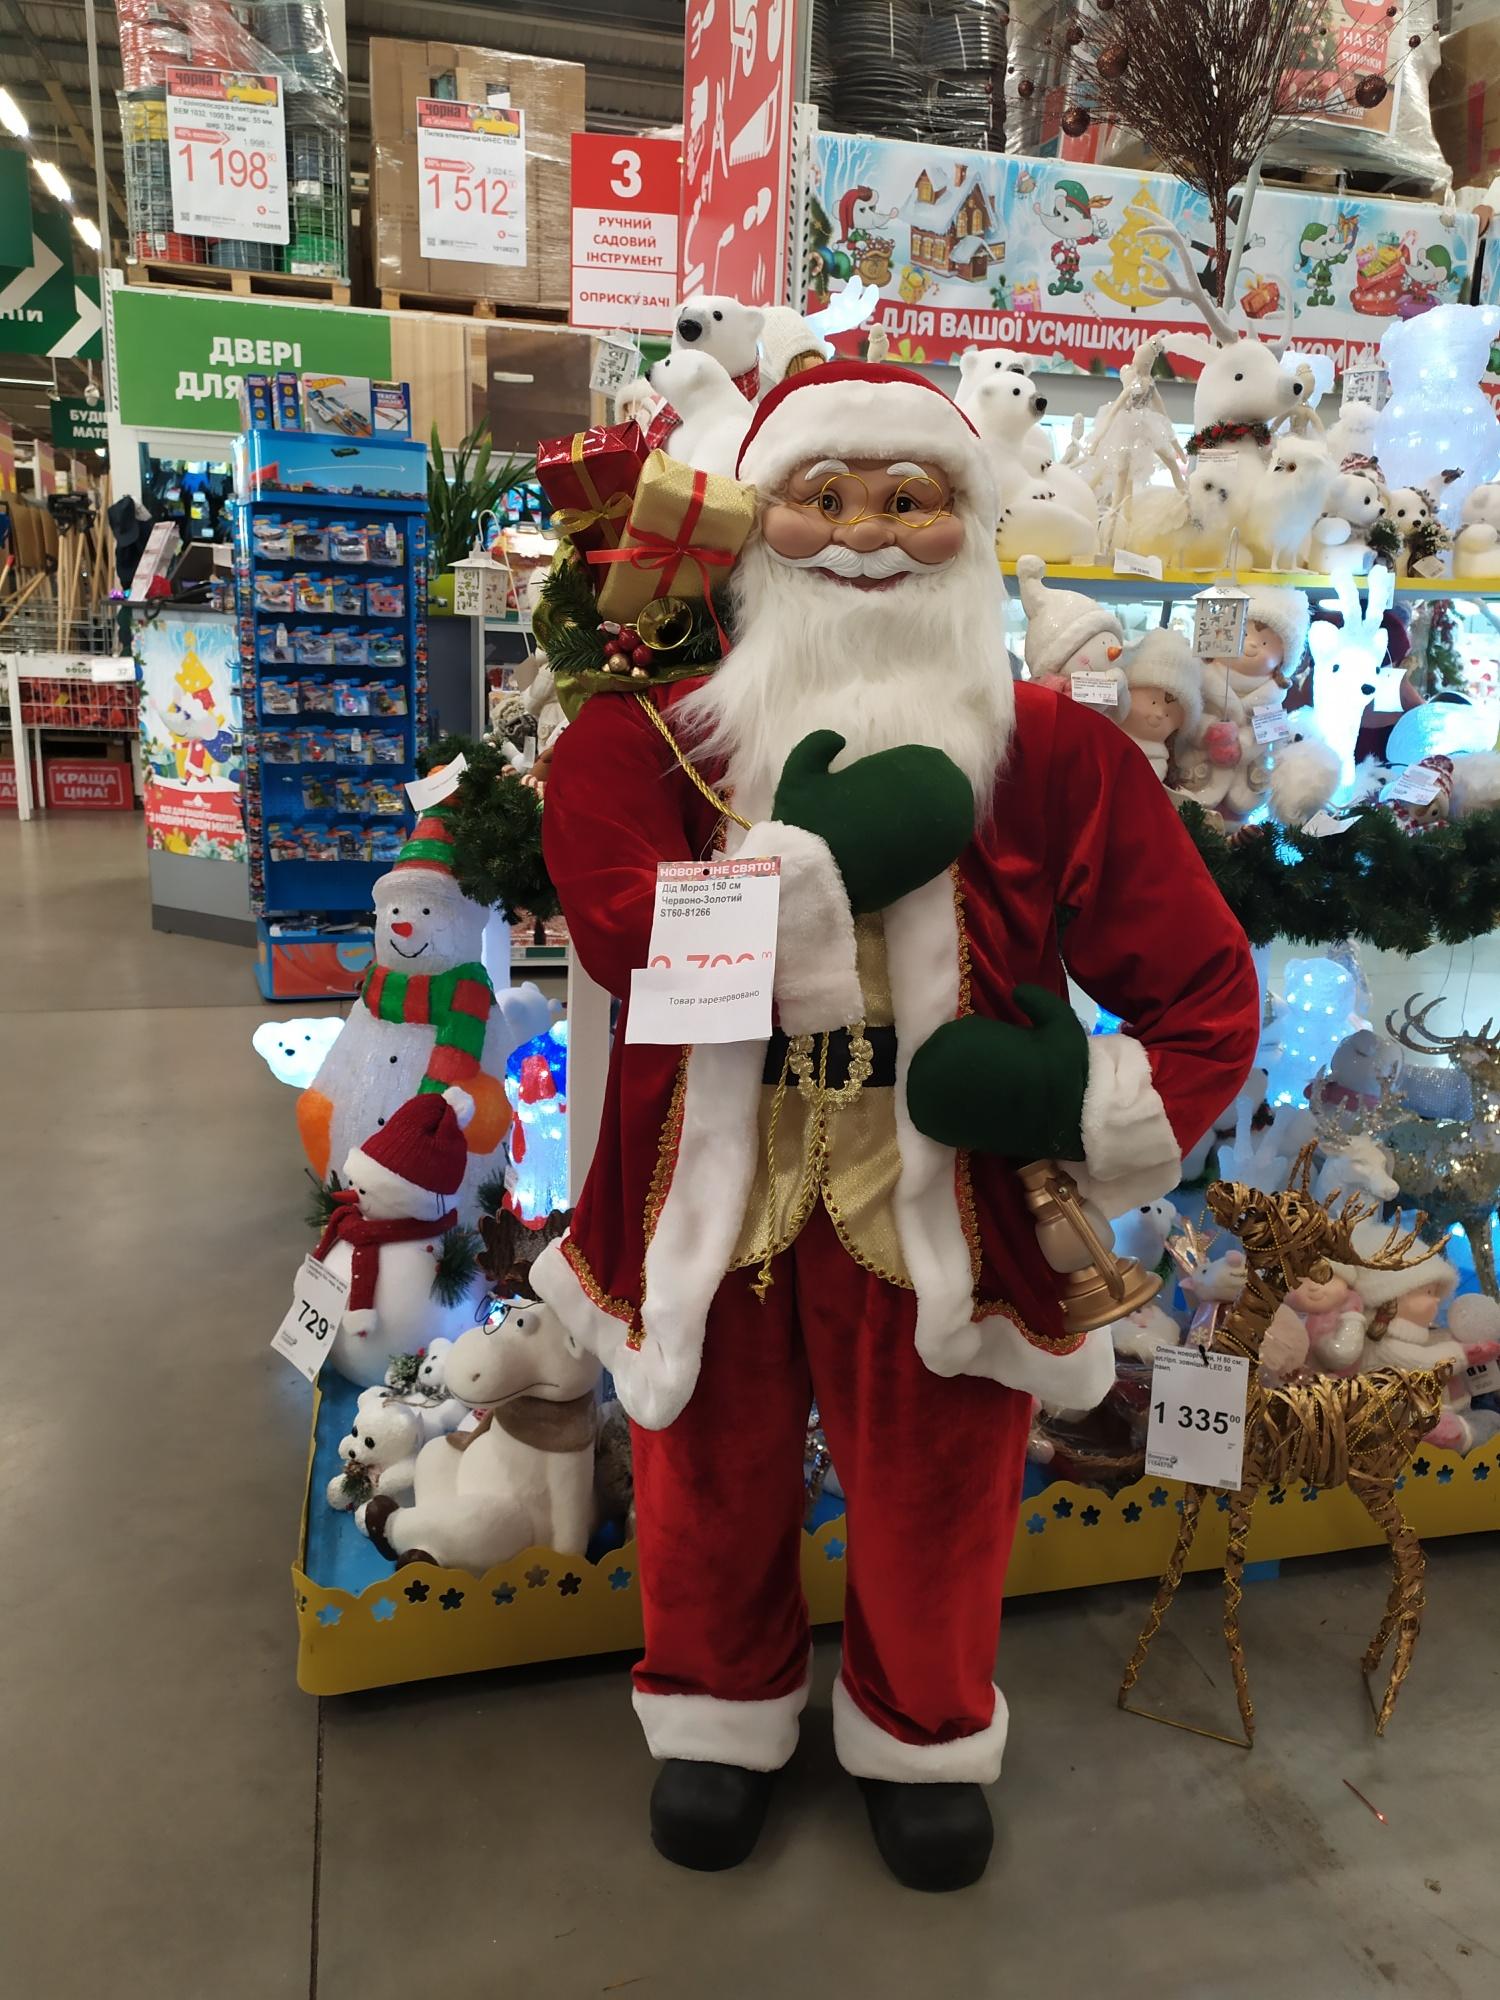Imagine if Santa Claus suddenly came to life. What would be the first thing he does? If Santa Claus came to life in the middle of the store, the first thing he might do is let out a hearty 'Ho, ho, ho!' to catch everyone's attention. His jolly voice would fill the store with excitement and draw a crowd of happy, astonished shoppers. Santa might then start handing out small festive treats to children, like candy canes or little gifts from his green sack. He could engage in friendly conversations with the customers, asking them about their Christmas wishes and spreading cheer. His presence would undoubtedly turn the shopping experience into a magical event, leaving everyone with a memorable and delightful encounter. And what if he had a special message for everyone in the store? If Santa had a special message for everyone in the store, he would likely gather everyone around and, with a warm and kind expression, he’d say: 'Remember, the true spirit of Christmas is not just in receiving but in giving and sharing love and joy with others. Embrace the festive season with kindness, gratitude, and the joy of being with family and friends. Take a moment to appreciate the simple pleasures, the laughter, and the warmth of togetherness. Merry Christmas to all, and to all a wonderful and joyous season!' His heartfelt words would resonate deeply, reminding everyone of the true essence of the holiday season. 